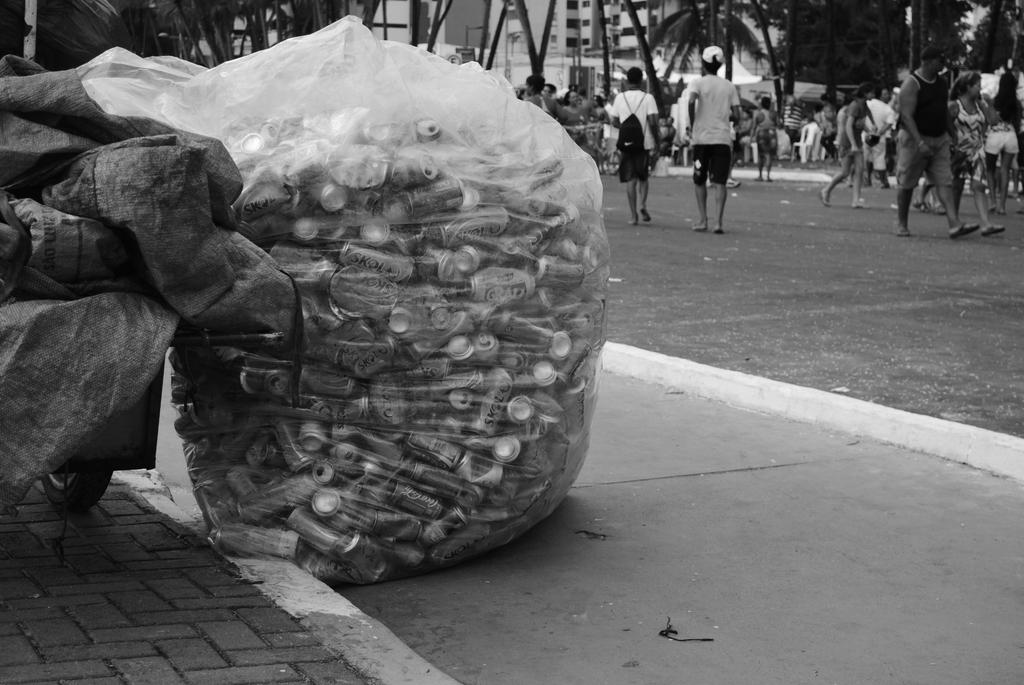Who or what is present in the image? There are people in the image. What objects can be seen with the people? There are tin cans in a plastic bag in the image. What type of natural environment is visible in the image? There are trees in the image. What type of man-made structures can be seen in the background? There are buildings in the background of the image. How is the image presented in terms of color? The image is black and white in color. What type of medical advice can be seen being given in the image? There is no medical advice or hospital setting present in the image. What type of artwork is being created in the image? There is no artwork or artist present in the image. 